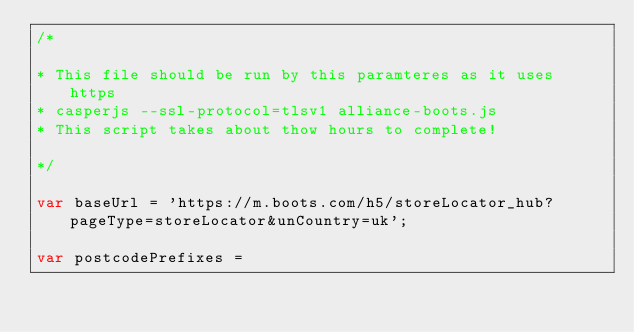Convert code to text. <code><loc_0><loc_0><loc_500><loc_500><_JavaScript_>/*

* This file should be run by this paramteres as it uses https
* casperjs --ssl-protocol=tlsv1 alliance-boots.js
* This script takes about thow hours to complete! 

*/

var baseUrl = 'https://m.boots.com/h5/storeLocator_hub?pageType=storeLocator&unCountry=uk';

var postcodePrefixes = </code> 